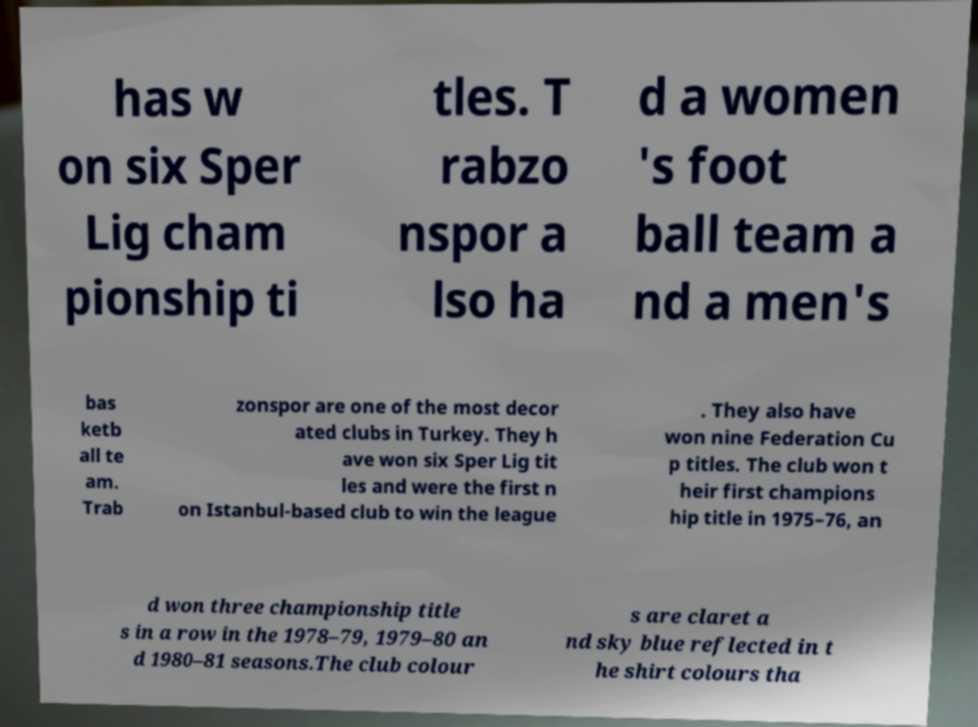There's text embedded in this image that I need extracted. Can you transcribe it verbatim? has w on six Sper Lig cham pionship ti tles. T rabzo nspor a lso ha d a women 's foot ball team a nd a men's bas ketb all te am. Trab zonspor are one of the most decor ated clubs in Turkey. They h ave won six Sper Lig tit les and were the first n on Istanbul-based club to win the league . They also have won nine Federation Cu p titles. The club won t heir first champions hip title in 1975–76, an d won three championship title s in a row in the 1978–79, 1979–80 an d 1980–81 seasons.The club colour s are claret a nd sky blue reflected in t he shirt colours tha 